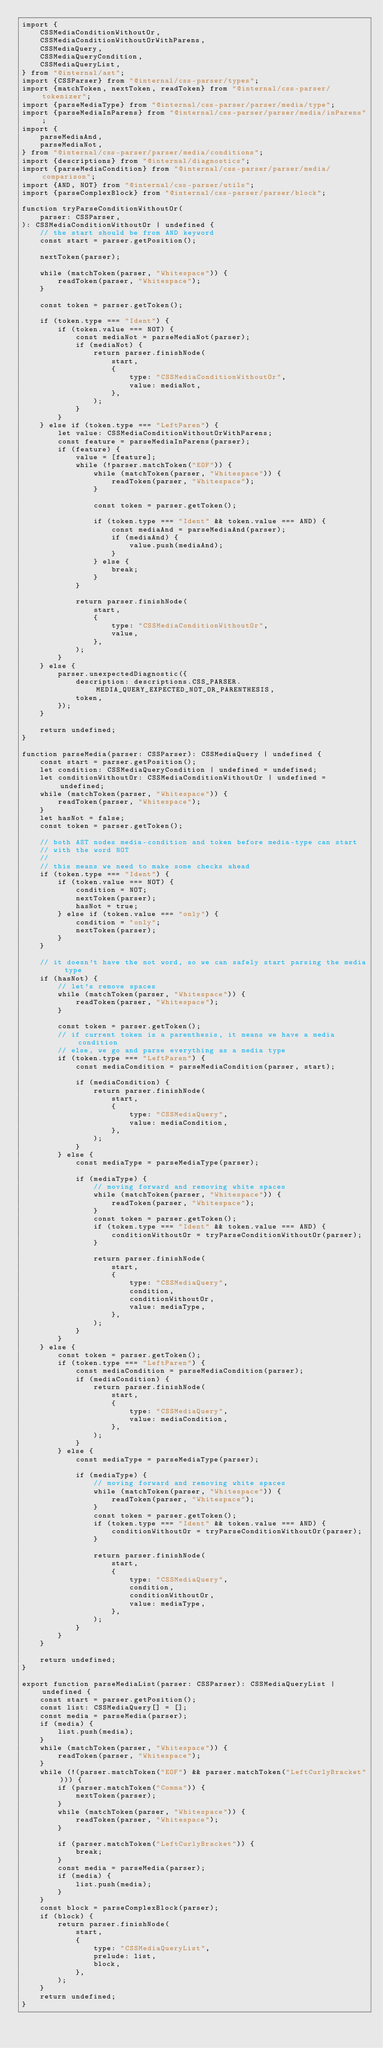<code> <loc_0><loc_0><loc_500><loc_500><_TypeScript_>import {
	CSSMediaConditionWithoutOr,
	CSSMediaConditionWithoutOrWithParens,
	CSSMediaQuery,
	CSSMediaQueryCondition,
	CSSMediaQueryList,
} from "@internal/ast";
import {CSSParser} from "@internal/css-parser/types";
import {matchToken, nextToken, readToken} from "@internal/css-parser/tokenizer";
import {parseMediaType} from "@internal/css-parser/parser/media/type";
import {parseMediaInParens} from "@internal/css-parser/parser/media/inParens";
import {
	parseMediaAnd,
	parseMediaNot,
} from "@internal/css-parser/parser/media/conditions";
import {descriptions} from "@internal/diagnostics";
import {parseMediaCondition} from "@internal/css-parser/parser/media/comparison";
import {AND, NOT} from "@internal/css-parser/utils";
import {parseComplexBlock} from "@internal/css-parser/parser/block";

function tryParseConditionWithoutOr(
	parser: CSSParser,
): CSSMediaConditionWithoutOr | undefined {
	// the start should be from AND keyword
	const start = parser.getPosition();

	nextToken(parser);

	while (matchToken(parser, "Whitespace")) {
		readToken(parser, "Whitespace");
	}

	const token = parser.getToken();

	if (token.type === "Ident") {
		if (token.value === NOT) {
			const mediaNot = parseMediaNot(parser);
			if (mediaNot) {
				return parser.finishNode(
					start,
					{
						type: "CSSMediaConditionWithoutOr",
						value: mediaNot,
					},
				);
			}
		}
	} else if (token.type === "LeftParen") {
		let value: CSSMediaConditionWithoutOrWithParens;
		const feature = parseMediaInParens(parser);
		if (feature) {
			value = [feature];
			while (!parser.matchToken("EOF")) {
				while (matchToken(parser, "Whitespace")) {
					readToken(parser, "Whitespace");
				}

				const token = parser.getToken();

				if (token.type === "Ident" && token.value === AND) {
					const mediaAnd = parseMediaAnd(parser);
					if (mediaAnd) {
						value.push(mediaAnd);
					}
				} else {
					break;
				}
			}

			return parser.finishNode(
				start,
				{
					type: "CSSMediaConditionWithoutOr",
					value,
				},
			);
		}
	} else {
		parser.unexpectedDiagnostic({
			description: descriptions.CSS_PARSER.MEDIA_QUERY_EXPECTED_NOT_OR_PARENTHESIS,
			token,
		});
	}

	return undefined;
}

function parseMedia(parser: CSSParser): CSSMediaQuery | undefined {
	const start = parser.getPosition();
	let condition: CSSMediaQueryCondition | undefined = undefined;
	let conditionWithoutOr: CSSMediaConditionWithoutOr | undefined = undefined;
	while (matchToken(parser, "Whitespace")) {
		readToken(parser, "Whitespace");
	}
	let hasNot = false;
	const token = parser.getToken();

	// both AST nodes media-condition and token before media-type can start
	// with the word NOT
	//
	// this means we need to make some checks ahead
	if (token.type === "Ident") {
		if (token.value === NOT) {
			condition = NOT;
			nextToken(parser);
			hasNot = true;
		} else if (token.value === "only") {
			condition = "only";
			nextToken(parser);
		}
	}

	// it doesn't have the not word, so we can safely start parsing the media type
	if (hasNot) {
		// let's remove spaces
		while (matchToken(parser, "Whitespace")) {
			readToken(parser, "Whitespace");
		}

		const token = parser.getToken();
		// if current token is a parenthesis, it means we have a media condition
		// else, we go and parse everything as a media type
		if (token.type === "LeftParen") {
			const mediaCondition = parseMediaCondition(parser, start);

			if (mediaCondition) {
				return parser.finishNode(
					start,
					{
						type: "CSSMediaQuery",
						value: mediaCondition,
					},
				);
			}
		} else {
			const mediaType = parseMediaType(parser);

			if (mediaType) {
				// moving forward and removing white spaces
				while (matchToken(parser, "Whitespace")) {
					readToken(parser, "Whitespace");
				}
				const token = parser.getToken();
				if (token.type === "Ident" && token.value === AND) {
					conditionWithoutOr = tryParseConditionWithoutOr(parser);
				}

				return parser.finishNode(
					start,
					{
						type: "CSSMediaQuery",
						condition,
						conditionWithoutOr,
						value: mediaType,
					},
				);
			}
		}
	} else {
		const token = parser.getToken();
		if (token.type === "LeftParen") {
			const mediaCondition = parseMediaCondition(parser);
			if (mediaCondition) {
				return parser.finishNode(
					start,
					{
						type: "CSSMediaQuery",
						value: mediaCondition,
					},
				);
			}
		} else {
			const mediaType = parseMediaType(parser);

			if (mediaType) {
				// moving forward and removing white spaces
				while (matchToken(parser, "Whitespace")) {
					readToken(parser, "Whitespace");
				}
				const token = parser.getToken();
				if (token.type === "Ident" && token.value === AND) {
					conditionWithoutOr = tryParseConditionWithoutOr(parser);
				}

				return parser.finishNode(
					start,
					{
						type: "CSSMediaQuery",
						condition,
						conditionWithoutOr,
						value: mediaType,
					},
				);
			}
		}
	}

	return undefined;
}

export function parseMediaList(parser: CSSParser): CSSMediaQueryList | undefined {
	const start = parser.getPosition();
	const list: CSSMediaQuery[] = [];
	const media = parseMedia(parser);
	if (media) {
		list.push(media);
	}
	while (matchToken(parser, "Whitespace")) {
		readToken(parser, "Whitespace");
	}
	while (!(parser.matchToken("EOF") && parser.matchToken("LeftCurlyBracket"))) {
		if (parser.matchToken("Comma")) {
			nextToken(parser);
		}
		while (matchToken(parser, "Whitespace")) {
			readToken(parser, "Whitespace");
		}

		if (parser.matchToken("LeftCurlyBracket")) {
			break;
		}
		const media = parseMedia(parser);
		if (media) {
			list.push(media);
		}
	}
	const block = parseComplexBlock(parser);
	if (block) {
		return parser.finishNode(
			start,
			{
				type: "CSSMediaQueryList",
				prelude: list,
				block,
			},
		);
	}
	return undefined;
}
</code> 